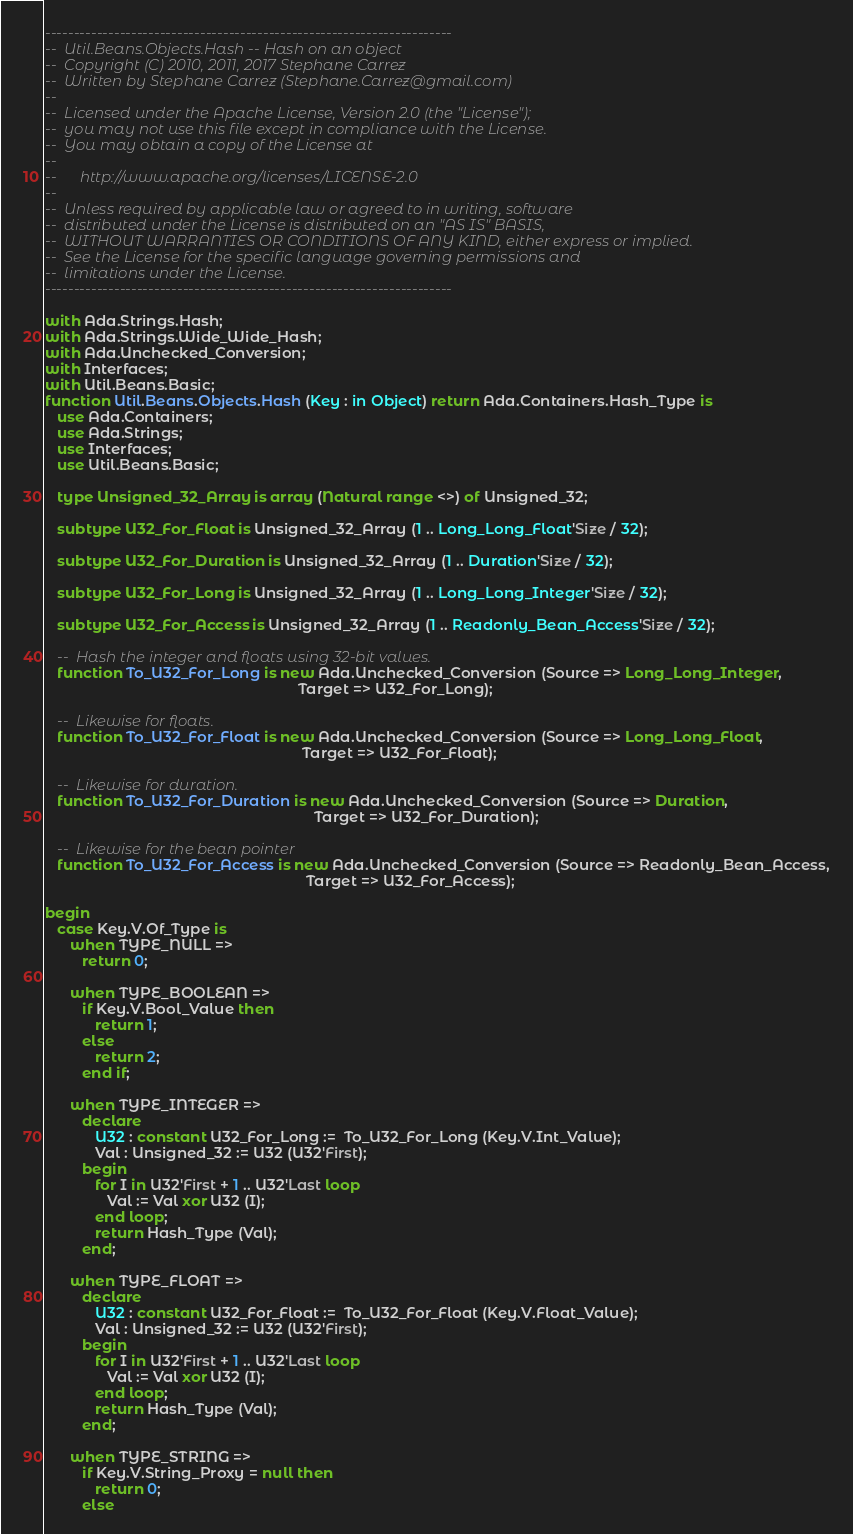<code> <loc_0><loc_0><loc_500><loc_500><_Ada_>-----------------------------------------------------------------------
--  Util.Beans.Objects.Hash -- Hash on an object
--  Copyright (C) 2010, 2011, 2017 Stephane Carrez
--  Written by Stephane Carrez (Stephane.Carrez@gmail.com)
--
--  Licensed under the Apache License, Version 2.0 (the "License");
--  you may not use this file except in compliance with the License.
--  You may obtain a copy of the License at
--
--      http://www.apache.org/licenses/LICENSE-2.0
--
--  Unless required by applicable law or agreed to in writing, software
--  distributed under the License is distributed on an "AS IS" BASIS,
--  WITHOUT WARRANTIES OR CONDITIONS OF ANY KIND, either express or implied.
--  See the License for the specific language governing permissions and
--  limitations under the License.
-----------------------------------------------------------------------

with Ada.Strings.Hash;
with Ada.Strings.Wide_Wide_Hash;
with Ada.Unchecked_Conversion;
with Interfaces;
with Util.Beans.Basic;
function Util.Beans.Objects.Hash (Key : in Object) return Ada.Containers.Hash_Type is
   use Ada.Containers;
   use Ada.Strings;
   use Interfaces;
   use Util.Beans.Basic;

   type Unsigned_32_Array is array (Natural range <>) of Unsigned_32;

   subtype U32_For_Float is Unsigned_32_Array (1 .. Long_Long_Float'Size / 32);

   subtype U32_For_Duration is Unsigned_32_Array (1 .. Duration'Size / 32);

   subtype U32_For_Long is Unsigned_32_Array (1 .. Long_Long_Integer'Size / 32);

   subtype U32_For_Access is Unsigned_32_Array (1 .. Readonly_Bean_Access'Size / 32);

   --  Hash the integer and floats using 32-bit values.
   function To_U32_For_Long is new Ada.Unchecked_Conversion (Source => Long_Long_Integer,
                                                             Target => U32_For_Long);

   --  Likewise for floats.
   function To_U32_For_Float is new Ada.Unchecked_Conversion (Source => Long_Long_Float,
                                                              Target => U32_For_Float);

   --  Likewise for duration.
   function To_U32_For_Duration is new Ada.Unchecked_Conversion (Source => Duration,
                                                                 Target => U32_For_Duration);

   --  Likewise for the bean pointer
   function To_U32_For_Access is new Ada.Unchecked_Conversion (Source => Readonly_Bean_Access,
                                                               Target => U32_For_Access);

begin
   case Key.V.Of_Type is
      when TYPE_NULL =>
         return 0;

      when TYPE_BOOLEAN =>
         if Key.V.Bool_Value then
            return 1;
         else
            return 2;
         end if;

      when TYPE_INTEGER =>
         declare
            U32 : constant U32_For_Long :=  To_U32_For_Long (Key.V.Int_Value);
            Val : Unsigned_32 := U32 (U32'First);
         begin
            for I in U32'First + 1 .. U32'Last loop
               Val := Val xor U32 (I);
            end loop;
            return Hash_Type (Val);
         end;

      when TYPE_FLOAT =>
         declare
            U32 : constant U32_For_Float :=  To_U32_For_Float (Key.V.Float_Value);
            Val : Unsigned_32 := U32 (U32'First);
         begin
            for I in U32'First + 1 .. U32'Last loop
               Val := Val xor U32 (I);
            end loop;
            return Hash_Type (Val);
         end;

      when TYPE_STRING =>
         if Key.V.String_Proxy = null then
            return 0;
         else</code> 